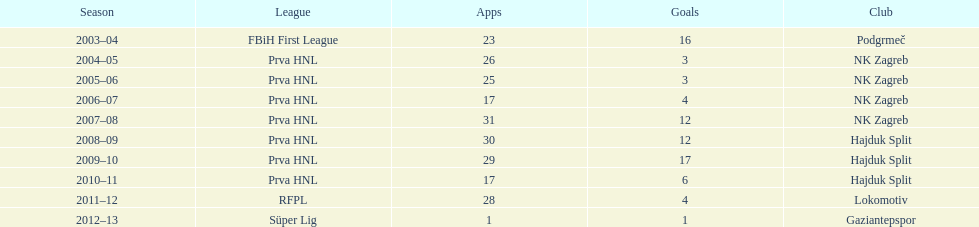What is the highest number of goals scored by senijad ibri&#269;i&#263; in a season? 35. 